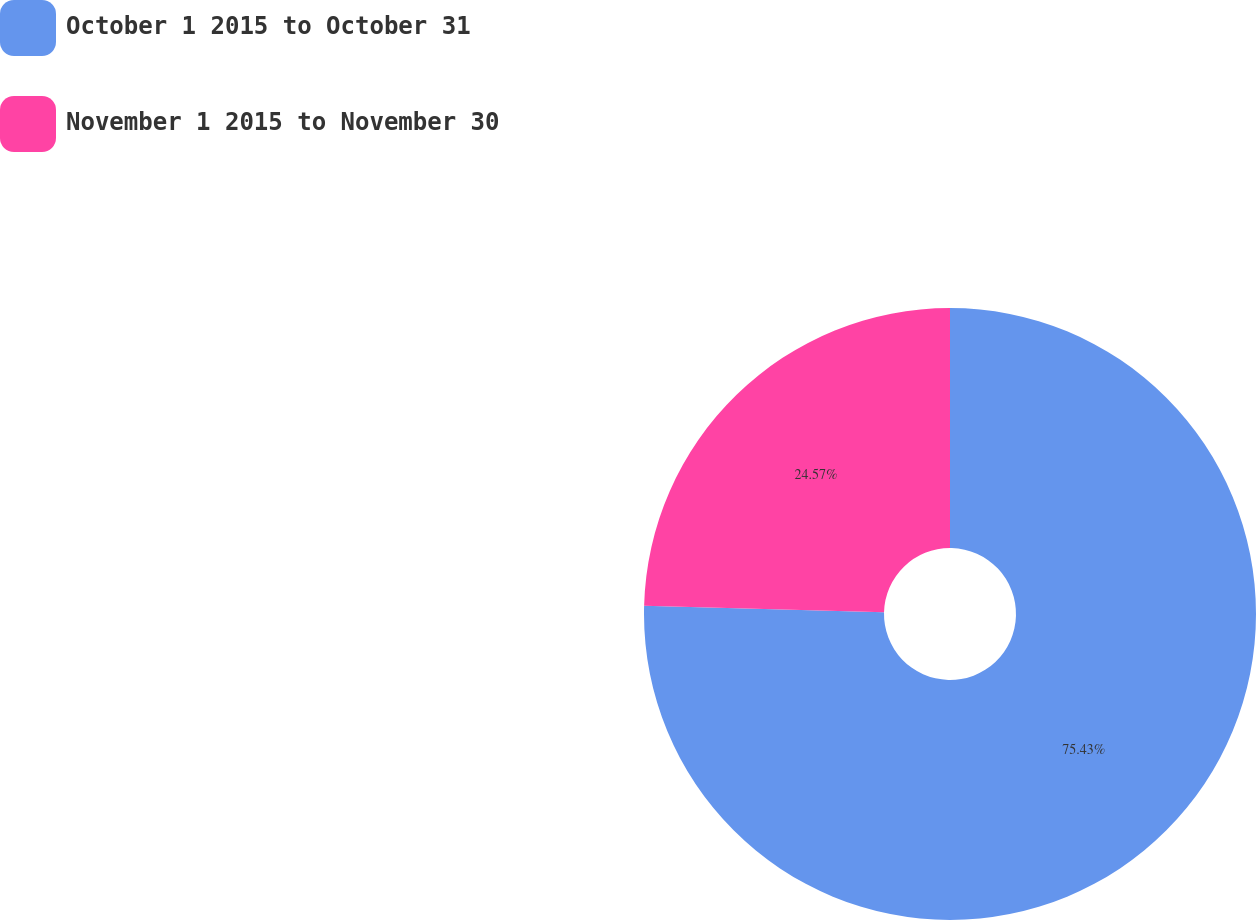Convert chart. <chart><loc_0><loc_0><loc_500><loc_500><pie_chart><fcel>October 1 2015 to October 31<fcel>November 1 2015 to November 30<nl><fcel>75.43%<fcel>24.57%<nl></chart> 